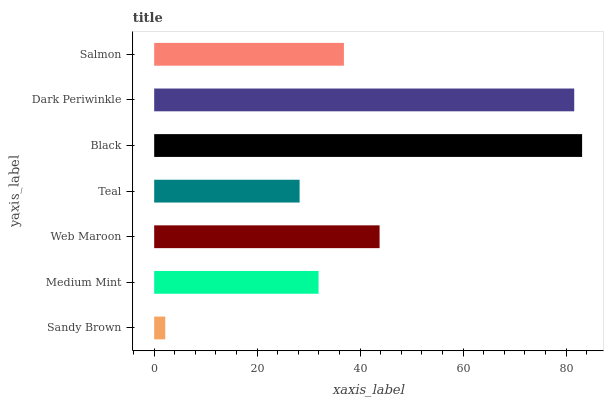Is Sandy Brown the minimum?
Answer yes or no. Yes. Is Black the maximum?
Answer yes or no. Yes. Is Medium Mint the minimum?
Answer yes or no. No. Is Medium Mint the maximum?
Answer yes or no. No. Is Medium Mint greater than Sandy Brown?
Answer yes or no. Yes. Is Sandy Brown less than Medium Mint?
Answer yes or no. Yes. Is Sandy Brown greater than Medium Mint?
Answer yes or no. No. Is Medium Mint less than Sandy Brown?
Answer yes or no. No. Is Salmon the high median?
Answer yes or no. Yes. Is Salmon the low median?
Answer yes or no. Yes. Is Black the high median?
Answer yes or no. No. Is Web Maroon the low median?
Answer yes or no. No. 